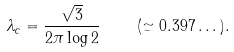<formula> <loc_0><loc_0><loc_500><loc_500>\lambda _ { c } = \frac { \sqrt { 3 } } { 2 \pi \log 2 } \quad ( \simeq 0 . 3 9 7 \dots ) .</formula> 